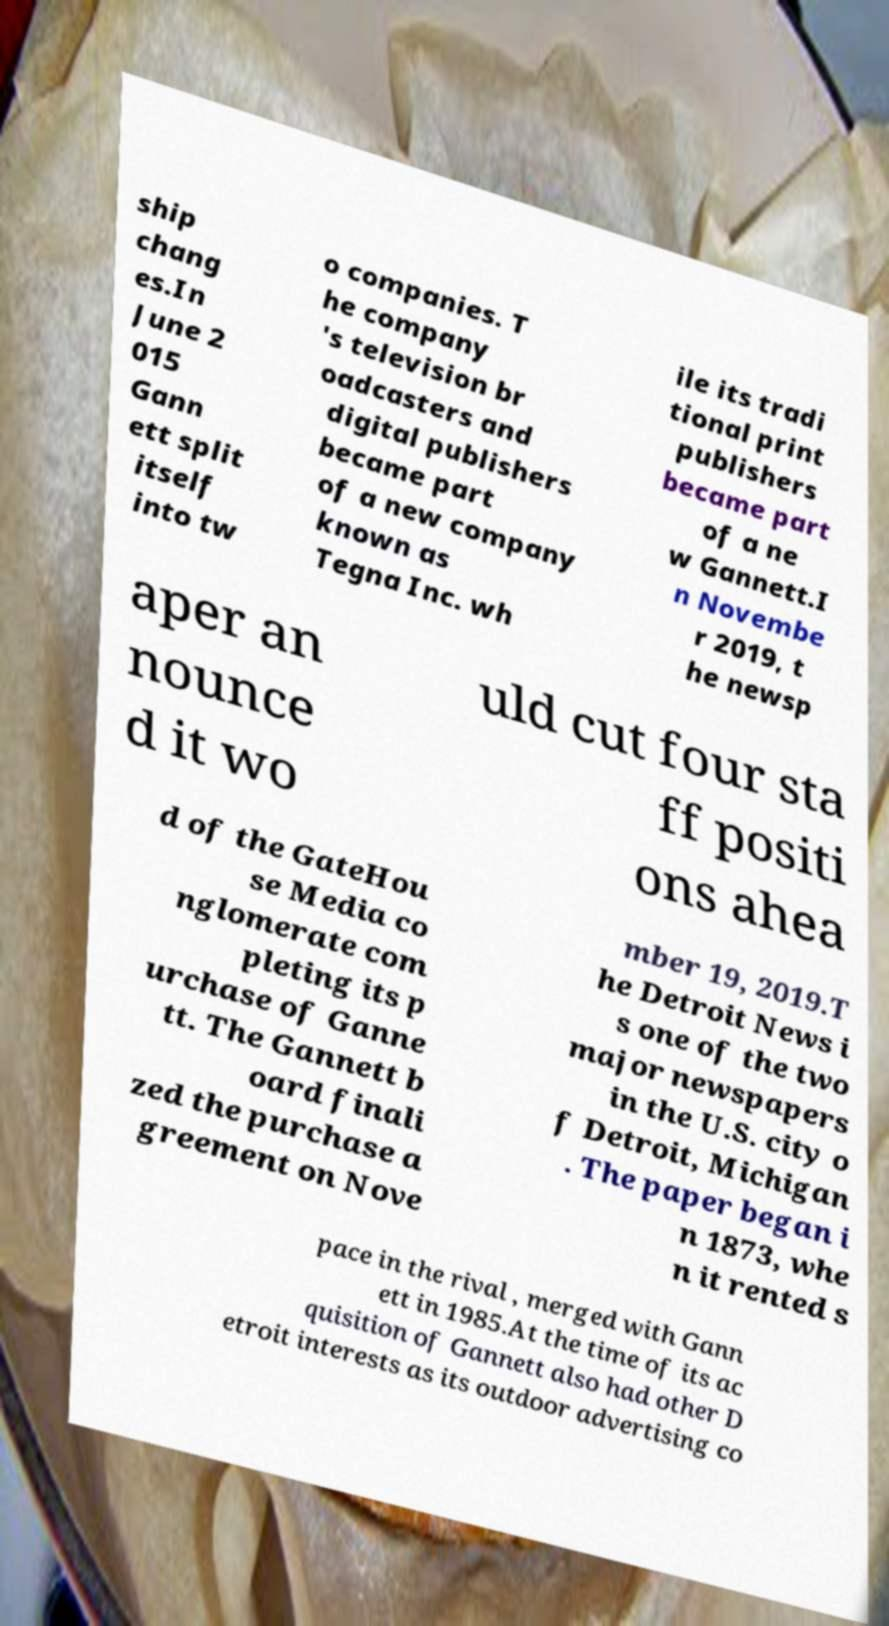For documentation purposes, I need the text within this image transcribed. Could you provide that? ship chang es.In June 2 015 Gann ett split itself into tw o companies. T he company 's television br oadcasters and digital publishers became part of a new company known as Tegna Inc. wh ile its tradi tional print publishers became part of a ne w Gannett.I n Novembe r 2019, t he newsp aper an nounce d it wo uld cut four sta ff positi ons ahea d of the GateHou se Media co nglomerate com pleting its p urchase of Ganne tt. The Gannett b oard finali zed the purchase a greement on Nove mber 19, 2019.T he Detroit News i s one of the two major newspapers in the U.S. city o f Detroit, Michigan . The paper began i n 1873, whe n it rented s pace in the rival , merged with Gann ett in 1985.At the time of its ac quisition of Gannett also had other D etroit interests as its outdoor advertising co 